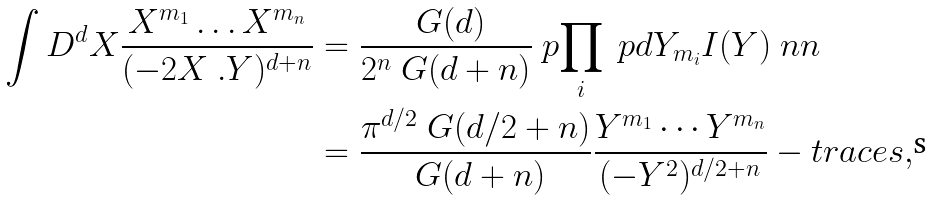Convert formula to latex. <formula><loc_0><loc_0><loc_500><loc_500>\int D ^ { d } X \frac { X ^ { m _ { 1 } } \dots X ^ { m _ { n } } } { ( - 2 X \ . Y ) ^ { d + n } } & = \frac { \ G ( d ) } { 2 ^ { n } \ G ( d + n ) } \ p { \prod _ { i } \ p d { Y _ { m _ { i } } } } I ( Y ) \ n n \\ & = \frac { \pi ^ { d / 2 } \ G ( d / 2 + n ) } { \ G ( d + n ) } \frac { Y ^ { m _ { 1 } } \cdots Y ^ { m _ { n } } } { ( - Y ^ { 2 } ) ^ { d / 2 + n } } - t r a c e s ,</formula> 